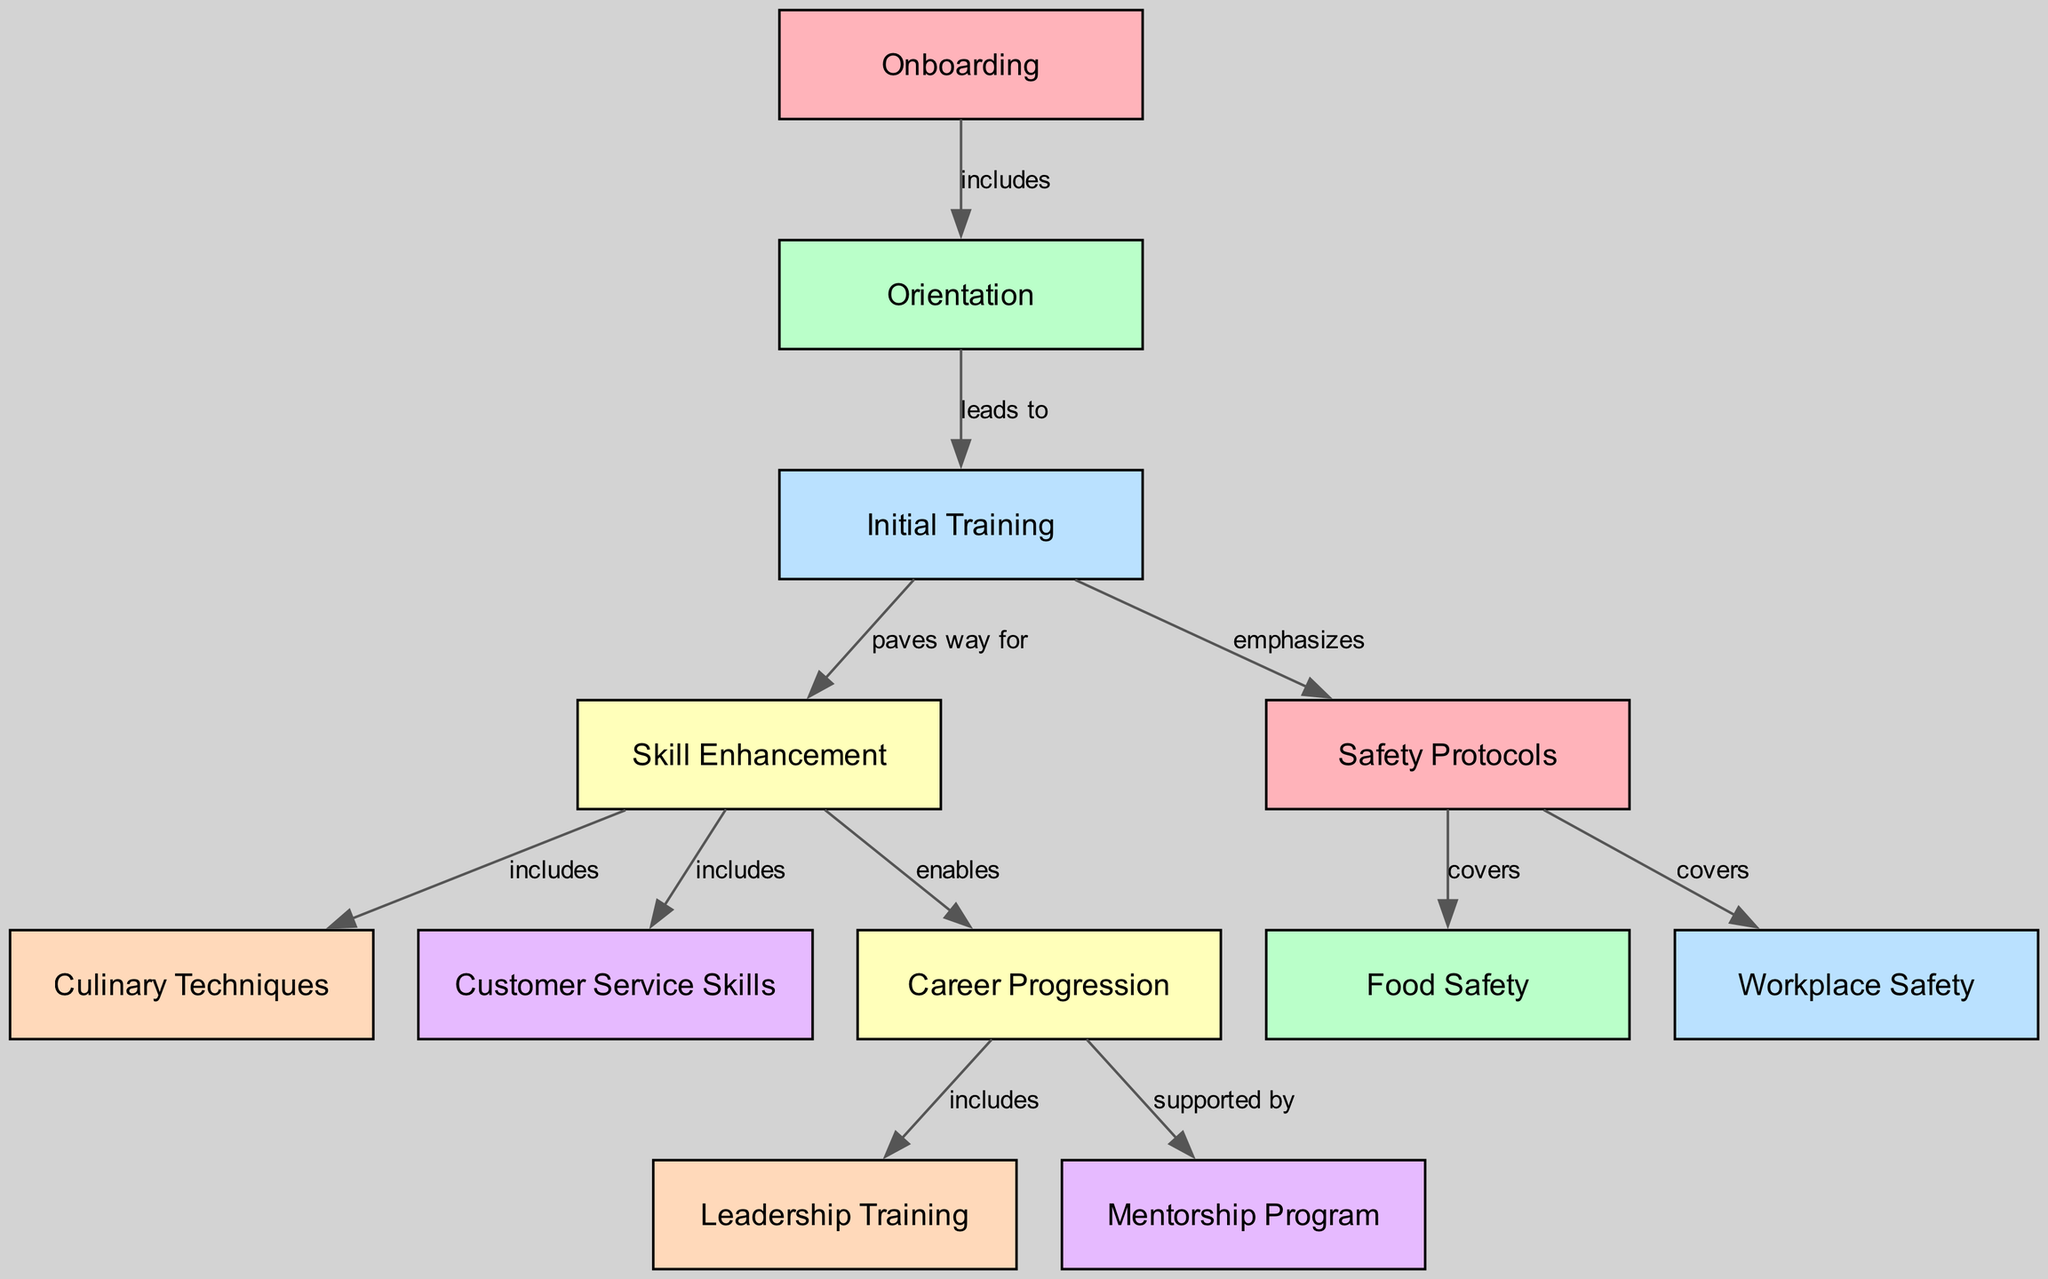What is the first stage in the employee training pathway? The diagram presents a sequence of training stages, starting with "Onboarding" as the first node.
Answer: Onboarding How many major stages are there in the employee training pathway? Counting through the nodes listed in the diagram, there are a total of 12 unique training-related nodes.
Answer: 12 What does "Initial Training" lead to? According to the diagram, "Initial Training" leads to "Skill Enhancement," indicating a progression from initial learning to advanced skill development.
Answer: Skill Enhancement Which training focus area emphasizes safety? The diagram shows that "Safety Protocols" is emphasized during "Initial Training," indicating it is a critical component of the early training stages.
Answer: Safety Protocols What supports "Career Progression"? The diagram indicates that "Career Progression" is supported by the "Mentorship Program," suggesting that mentorship plays a role in helping employees advance in their careers.
Answer: Mentorship Program How many edges connect "Skill Enhancement" to other stages? By reviewing the diagram, there are three edges stemming from "Skill Enhancement," connecting it to "Culinary Techniques," "Customer Service Skills," and "Career Progression."
Answer: 3 What are the two training areas included in "Skill Enhancement"? The diagram specifies that "Skill Enhancement" includes "Culinary Techniques" and "Customer Service Skills," highlighting these as key areas for employee development.
Answer: Culinary Techniques, Customer Service Skills What does "Safety Protocols" cover? The diagram elaborates that "Safety Protocols" covers both "Food Safety" and "Workplace Safety," ensuring comprehensive safety training for employees.
Answer: Food Safety, Workplace Safety What is the label of the edge that connects "Initial Training" to "Safety Protocols"? The edge from "Initial Training" to "Safety Protocols" is labeled as "emphasizes," indicating a focus on safety aspects during this training stage.
Answer: emphasizes 